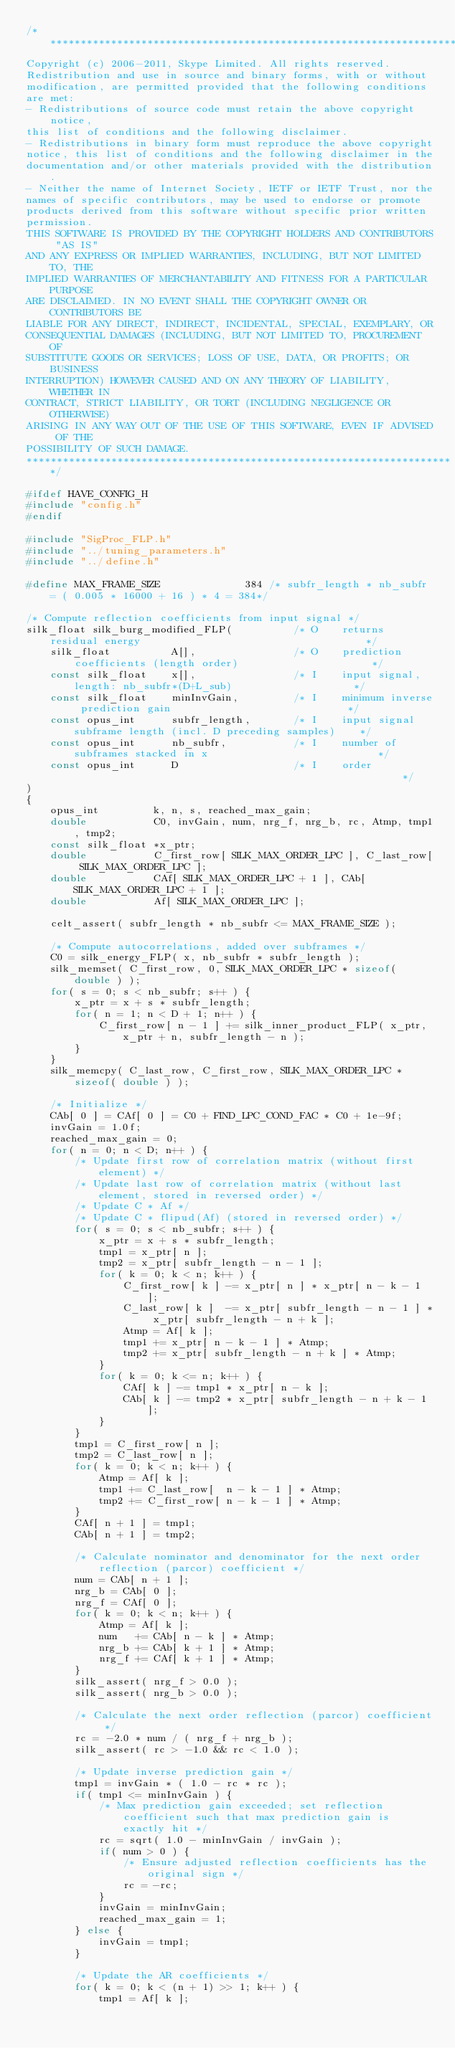<code> <loc_0><loc_0><loc_500><loc_500><_C_>/***********************************************************************
Copyright (c) 2006-2011, Skype Limited. All rights reserved.
Redistribution and use in source and binary forms, with or without
modification, are permitted provided that the following conditions
are met:
- Redistributions of source code must retain the above copyright notice,
this list of conditions and the following disclaimer.
- Redistributions in binary form must reproduce the above copyright
notice, this list of conditions and the following disclaimer in the
documentation and/or other materials provided with the distribution.
- Neither the name of Internet Society, IETF or IETF Trust, nor the
names of specific contributors, may be used to endorse or promote
products derived from this software without specific prior written
permission.
THIS SOFTWARE IS PROVIDED BY THE COPYRIGHT HOLDERS AND CONTRIBUTORS "AS IS"
AND ANY EXPRESS OR IMPLIED WARRANTIES, INCLUDING, BUT NOT LIMITED TO, THE
IMPLIED WARRANTIES OF MERCHANTABILITY AND FITNESS FOR A PARTICULAR PURPOSE
ARE DISCLAIMED. IN NO EVENT SHALL THE COPYRIGHT OWNER OR CONTRIBUTORS BE
LIABLE FOR ANY DIRECT, INDIRECT, INCIDENTAL, SPECIAL, EXEMPLARY, OR
CONSEQUENTIAL DAMAGES (INCLUDING, BUT NOT LIMITED TO, PROCUREMENT OF
SUBSTITUTE GOODS OR SERVICES; LOSS OF USE, DATA, OR PROFITS; OR BUSINESS
INTERRUPTION) HOWEVER CAUSED AND ON ANY THEORY OF LIABILITY, WHETHER IN
CONTRACT, STRICT LIABILITY, OR TORT (INCLUDING NEGLIGENCE OR OTHERWISE)
ARISING IN ANY WAY OUT OF THE USE OF THIS SOFTWARE, EVEN IF ADVISED OF THE
POSSIBILITY OF SUCH DAMAGE.
***********************************************************************/

#ifdef HAVE_CONFIG_H
#include "config.h"
#endif

#include "SigProc_FLP.h"
#include "../tuning_parameters.h"
#include "../define.h"

#define MAX_FRAME_SIZE              384 /* subfr_length * nb_subfr = ( 0.005 * 16000 + 16 ) * 4 = 384*/

/* Compute reflection coefficients from input signal */
silk_float silk_burg_modified_FLP(          /* O    returns residual energy                                     */
    silk_float          A[],                /* O    prediction coefficients (length order)                      */
    const silk_float    x[],                /* I    input signal, length: nb_subfr*(D+L_sub)                    */
    const silk_float    minInvGain,         /* I    minimum inverse prediction gain                             */
    const opus_int      subfr_length,       /* I    input signal subframe length (incl. D preceding samples)    */
    const opus_int      nb_subfr,           /* I    number of subframes stacked in x                            */
    const opus_int      D                   /* I    order                                                       */
)
{
    opus_int         k, n, s, reached_max_gain;
    double           C0, invGain, num, nrg_f, nrg_b, rc, Atmp, tmp1, tmp2;
    const silk_float *x_ptr;
    double           C_first_row[ SILK_MAX_ORDER_LPC ], C_last_row[ SILK_MAX_ORDER_LPC ];
    double           CAf[ SILK_MAX_ORDER_LPC + 1 ], CAb[ SILK_MAX_ORDER_LPC + 1 ];
    double           Af[ SILK_MAX_ORDER_LPC ];

    celt_assert( subfr_length * nb_subfr <= MAX_FRAME_SIZE );

    /* Compute autocorrelations, added over subframes */
    C0 = silk_energy_FLP( x, nb_subfr * subfr_length );
    silk_memset( C_first_row, 0, SILK_MAX_ORDER_LPC * sizeof( double ) );
    for( s = 0; s < nb_subfr; s++ ) {
        x_ptr = x + s * subfr_length;
        for( n = 1; n < D + 1; n++ ) {
            C_first_row[ n - 1 ] += silk_inner_product_FLP( x_ptr, x_ptr + n, subfr_length - n );
        }
    }
    silk_memcpy( C_last_row, C_first_row, SILK_MAX_ORDER_LPC * sizeof( double ) );

    /* Initialize */
    CAb[ 0 ] = CAf[ 0 ] = C0 + FIND_LPC_COND_FAC * C0 + 1e-9f;
    invGain = 1.0f;
    reached_max_gain = 0;
    for( n = 0; n < D; n++ ) {
        /* Update first row of correlation matrix (without first element) */
        /* Update last row of correlation matrix (without last element, stored in reversed order) */
        /* Update C * Af */
        /* Update C * flipud(Af) (stored in reversed order) */
        for( s = 0; s < nb_subfr; s++ ) {
            x_ptr = x + s * subfr_length;
            tmp1 = x_ptr[ n ];
            tmp2 = x_ptr[ subfr_length - n - 1 ];
            for( k = 0; k < n; k++ ) {
                C_first_row[ k ] -= x_ptr[ n ] * x_ptr[ n - k - 1 ];
                C_last_row[ k ]  -= x_ptr[ subfr_length - n - 1 ] * x_ptr[ subfr_length - n + k ];
                Atmp = Af[ k ];
                tmp1 += x_ptr[ n - k - 1 ] * Atmp;
                tmp2 += x_ptr[ subfr_length - n + k ] * Atmp;
            }
            for( k = 0; k <= n; k++ ) {
                CAf[ k ] -= tmp1 * x_ptr[ n - k ];
                CAb[ k ] -= tmp2 * x_ptr[ subfr_length - n + k - 1 ];
            }
        }
        tmp1 = C_first_row[ n ];
        tmp2 = C_last_row[ n ];
        for( k = 0; k < n; k++ ) {
            Atmp = Af[ k ];
            tmp1 += C_last_row[  n - k - 1 ] * Atmp;
            tmp2 += C_first_row[ n - k - 1 ] * Atmp;
        }
        CAf[ n + 1 ] = tmp1;
        CAb[ n + 1 ] = tmp2;

        /* Calculate nominator and denominator for the next order reflection (parcor) coefficient */
        num = CAb[ n + 1 ];
        nrg_b = CAb[ 0 ];
        nrg_f = CAf[ 0 ];
        for( k = 0; k < n; k++ ) {
            Atmp = Af[ k ];
            num   += CAb[ n - k ] * Atmp;
            nrg_b += CAb[ k + 1 ] * Atmp;
            nrg_f += CAf[ k + 1 ] * Atmp;
        }
        silk_assert( nrg_f > 0.0 );
        silk_assert( nrg_b > 0.0 );

        /* Calculate the next order reflection (parcor) coefficient */
        rc = -2.0 * num / ( nrg_f + nrg_b );
        silk_assert( rc > -1.0 && rc < 1.0 );

        /* Update inverse prediction gain */
        tmp1 = invGain * ( 1.0 - rc * rc );
        if( tmp1 <= minInvGain ) {
            /* Max prediction gain exceeded; set reflection coefficient such that max prediction gain is exactly hit */
            rc = sqrt( 1.0 - minInvGain / invGain );
            if( num > 0 ) {
                /* Ensure adjusted reflection coefficients has the original sign */
                rc = -rc;
            }
            invGain = minInvGain;
            reached_max_gain = 1;
        } else {
            invGain = tmp1;
        }

        /* Update the AR coefficients */
        for( k = 0; k < (n + 1) >> 1; k++ ) {
            tmp1 = Af[ k ];</code> 